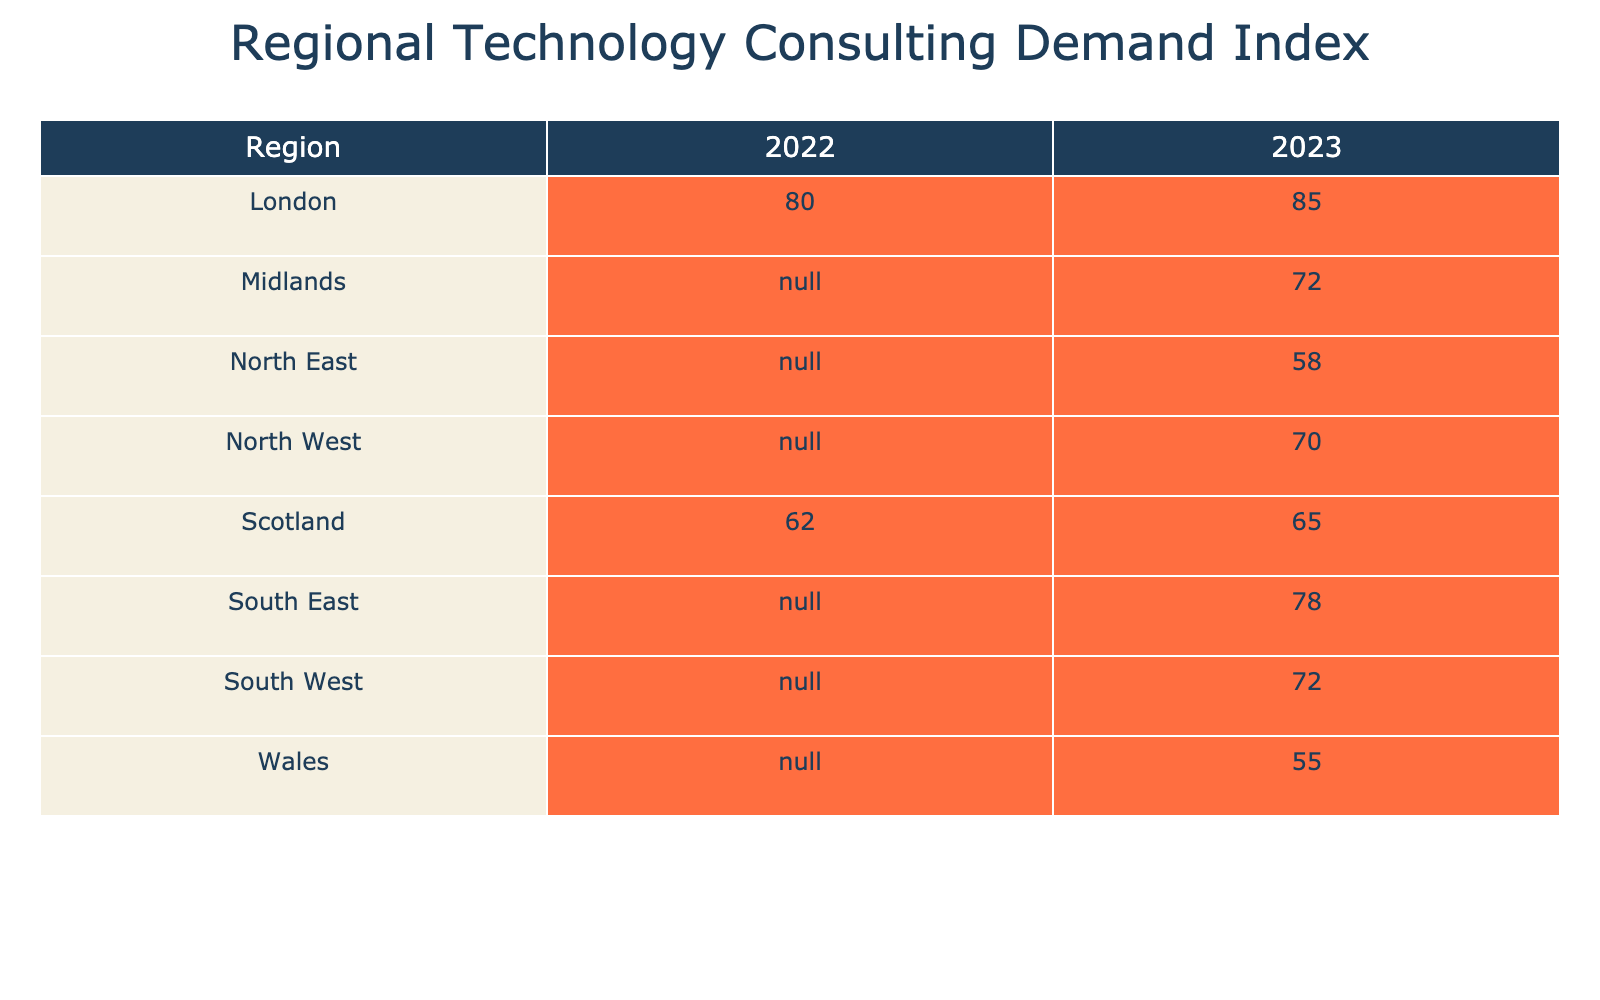What is the Technology Consulting Demand Index for Scotland in 2023? The index value for Scotland in 2023 is listed in the table under the corresponding row and year. It shows a demand index of 65.
Answer: 65 Which region has the highest Technology Consulting Demand Index in 2022? The table shows the demand index for each region in 2022. Among them, London has the highest index at 80.
Answer: London What is the difference in Technology Consulting Demand Index between London and Scotland in 2022? To find the difference, subtract the index for Scotland in 2022 (62) from the index for London in 2022 (80). This results in a difference of 80 - 62 = 18.
Answer: 18 Does the North East have a Technology Consulting Demand Index higher than 60 in 2023? Checking the index for the North East in 2023, it is 58, which is not higher than 60. Therefore, the answer is no.
Answer: No What is the average Technology Consulting Demand Index for all regions listed in 2023? First, sum the indices: 85 (London) + 65 (Scotland) + 70 (North West) + 78 (South East) + 72 (Midlands) + 58 (North East) + 55 (Wales) + 72 (South West) = 485. Then divide by the number of regions (8), so the average is 485 / 8 = 60.625.
Answer: 60.625 Which consulting firm is associated with the highest Technology Consulting Demand Index in 2023? According to the table, London, with a demand index of 85, is associated with Accenture, making it the highest.
Answer: Accenture For which region did the Technology Consulting Demand Index improve from 2022 to 2023? By comparing the values, Scotland increased from 62 in 2022 to 65 in 2023, indicating an improvement.
Answer: Scotland Is the Technology Consulting Demand Index for Wales lower than the overall average in 2023? The index for Wales is 55, while the average calculated for 2023 is approximately 60.625. Thus, 55 is lower than this average.
Answer: Yes 